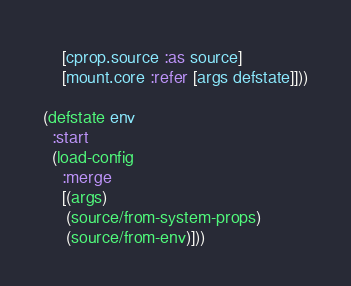Convert code to text. <code><loc_0><loc_0><loc_500><loc_500><_Clojure_>    [cprop.source :as source]
    [mount.core :refer [args defstate]]))

(defstate env
  :start
  (load-config
    :merge
    [(args)
     (source/from-system-props)
     (source/from-env)]))
</code> 